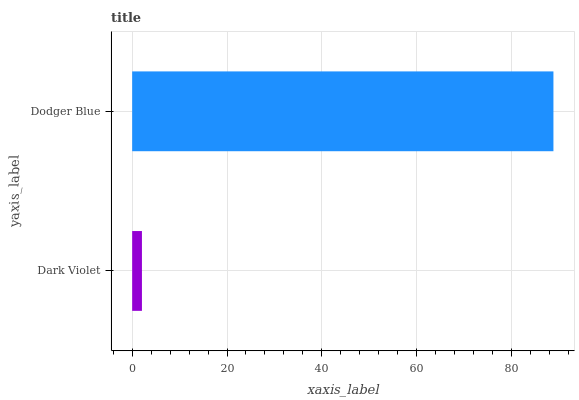Is Dark Violet the minimum?
Answer yes or no. Yes. Is Dodger Blue the maximum?
Answer yes or no. Yes. Is Dodger Blue the minimum?
Answer yes or no. No. Is Dodger Blue greater than Dark Violet?
Answer yes or no. Yes. Is Dark Violet less than Dodger Blue?
Answer yes or no. Yes. Is Dark Violet greater than Dodger Blue?
Answer yes or no. No. Is Dodger Blue less than Dark Violet?
Answer yes or no. No. Is Dodger Blue the high median?
Answer yes or no. Yes. Is Dark Violet the low median?
Answer yes or no. Yes. Is Dark Violet the high median?
Answer yes or no. No. Is Dodger Blue the low median?
Answer yes or no. No. 